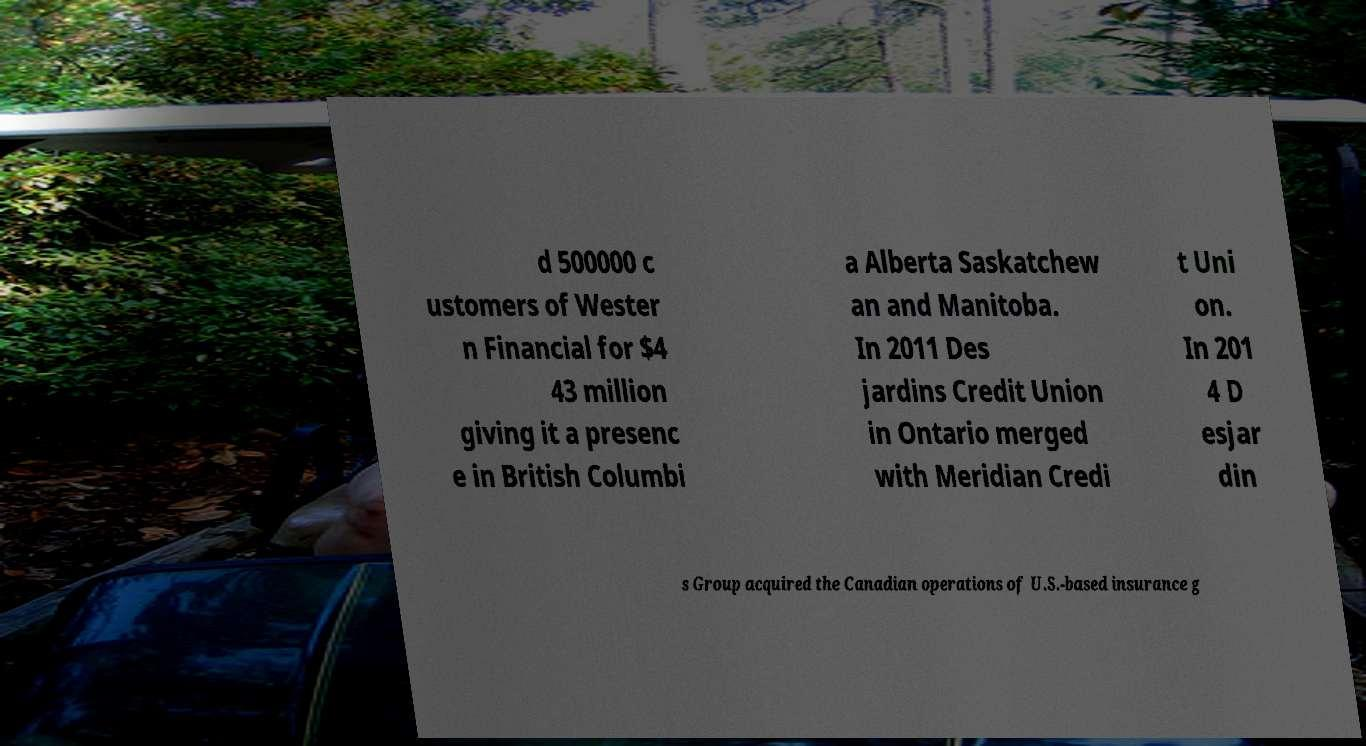Please read and relay the text visible in this image. What does it say? d 500000 c ustomers of Wester n Financial for $4 43 million giving it a presenc e in British Columbi a Alberta Saskatchew an and Manitoba. In 2011 Des jardins Credit Union in Ontario merged with Meridian Credi t Uni on. In 201 4 D esjar din s Group acquired the Canadian operations of U.S.-based insurance g 